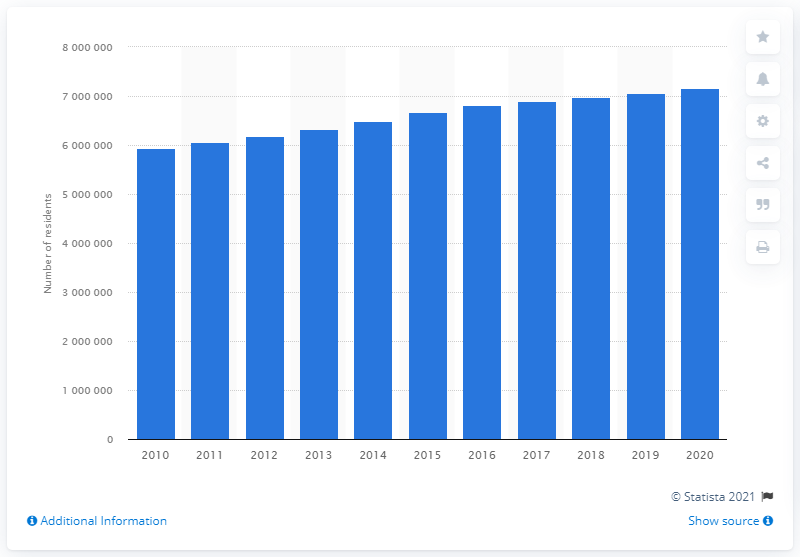Draw attention to some important aspects in this diagram. In the previous year, the population of the Houston-The Woodlands-Sugar Land metropolitan area was approximately 7,063,400. The population of the Houston-The Woodlands-Sugar Land metropolitan area in 2020 was 7,154,478. 